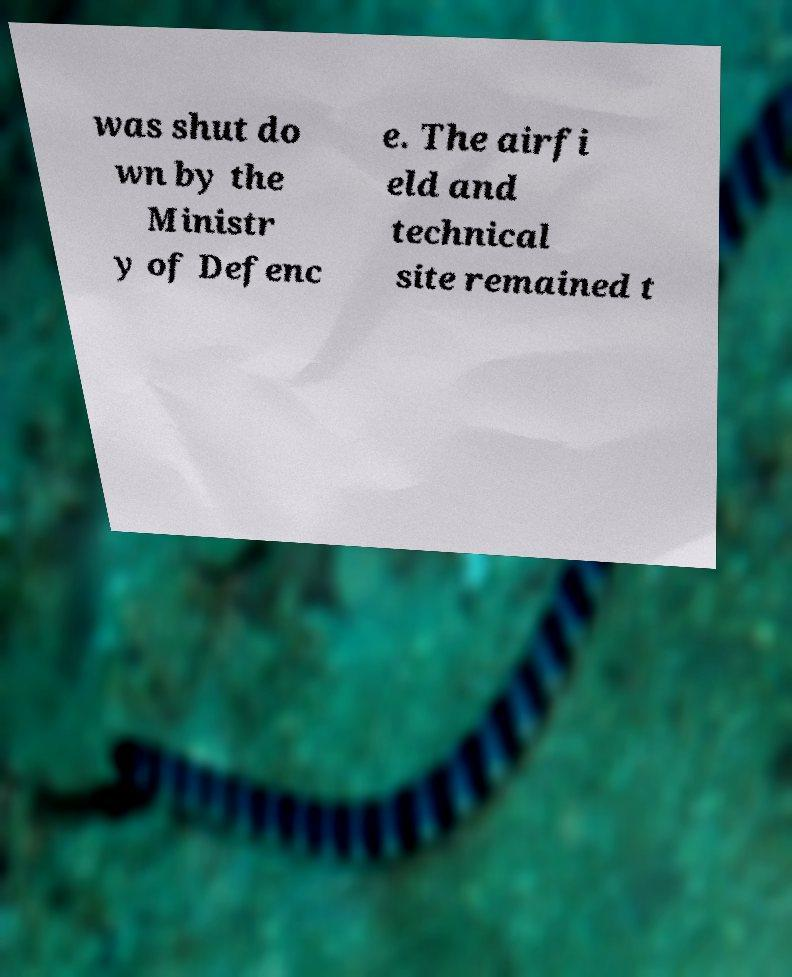For documentation purposes, I need the text within this image transcribed. Could you provide that? was shut do wn by the Ministr y of Defenc e. The airfi eld and technical site remained t 